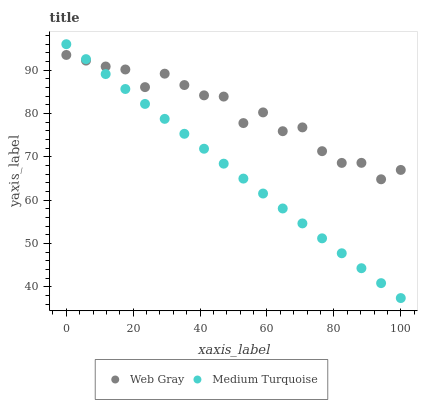Does Medium Turquoise have the minimum area under the curve?
Answer yes or no. Yes. Does Web Gray have the maximum area under the curve?
Answer yes or no. Yes. Does Medium Turquoise have the maximum area under the curve?
Answer yes or no. No. Is Medium Turquoise the smoothest?
Answer yes or no. Yes. Is Web Gray the roughest?
Answer yes or no. Yes. Is Medium Turquoise the roughest?
Answer yes or no. No. Does Medium Turquoise have the lowest value?
Answer yes or no. Yes. Does Medium Turquoise have the highest value?
Answer yes or no. Yes. Does Medium Turquoise intersect Web Gray?
Answer yes or no. Yes. Is Medium Turquoise less than Web Gray?
Answer yes or no. No. Is Medium Turquoise greater than Web Gray?
Answer yes or no. No. 